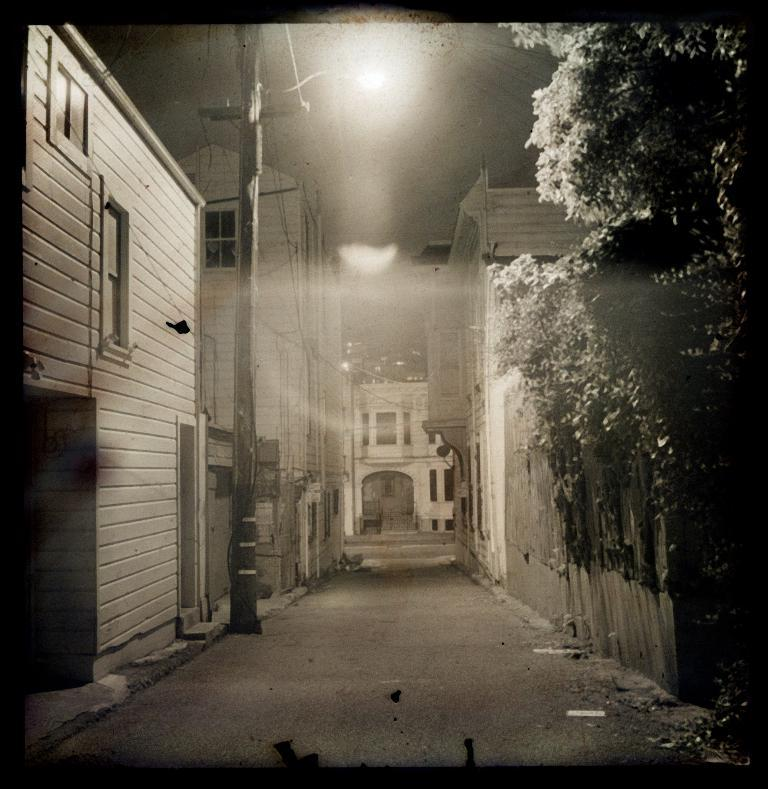What type of structures can be seen on both sides of the image? There are houses on both the right and left sides of the image. What type of vegetation is present in the image? There are trees in the image. What else can be seen in the image besides houses and trees? There are wires and a building in the background of the image. What is the purpose of the walkway at the bottom of the image? The walkway at the bottom of the image provides a path for people to walk on. What type of vegetable is growing on the roof of the building in the image? There are no vegetables visible in the image, and the roof of the building is not shown. 